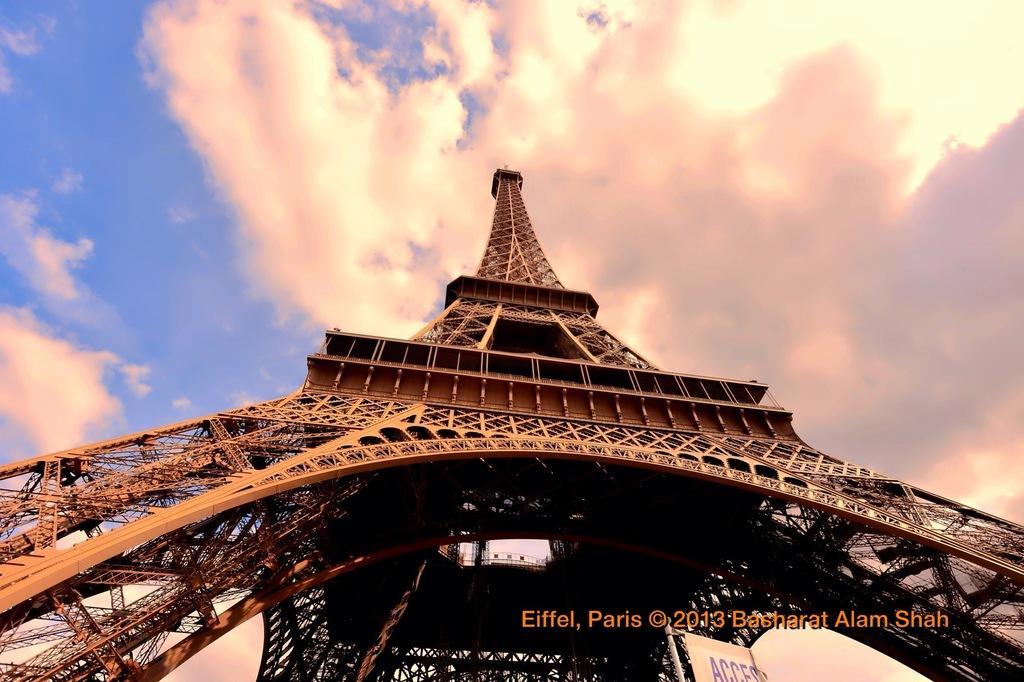Can you describe this image briefly? In the center of the image there is an eiffel tower. In the background there is sky and clouds. 